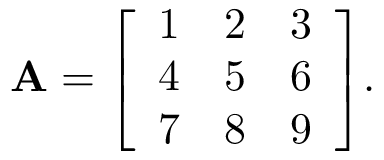Convert formula to latex. <formula><loc_0><loc_0><loc_500><loc_500>A = { \left [ \begin{array} { l l l } { 1 } & { 2 } & { 3 } \\ { 4 } & { 5 } & { 6 } \\ { 7 } & { 8 } & { 9 } \end{array} \right ] } .</formula> 